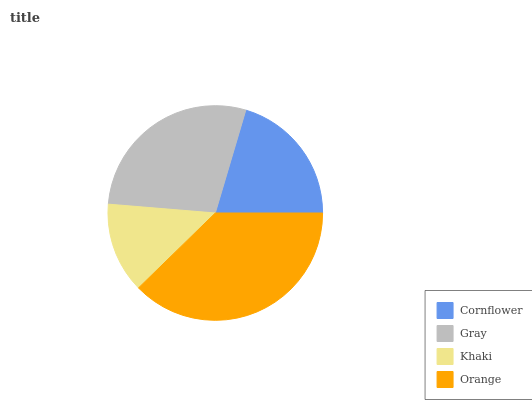Is Khaki the minimum?
Answer yes or no. Yes. Is Orange the maximum?
Answer yes or no. Yes. Is Gray the minimum?
Answer yes or no. No. Is Gray the maximum?
Answer yes or no. No. Is Gray greater than Cornflower?
Answer yes or no. Yes. Is Cornflower less than Gray?
Answer yes or no. Yes. Is Cornflower greater than Gray?
Answer yes or no. No. Is Gray less than Cornflower?
Answer yes or no. No. Is Gray the high median?
Answer yes or no. Yes. Is Cornflower the low median?
Answer yes or no. Yes. Is Cornflower the high median?
Answer yes or no. No. Is Orange the low median?
Answer yes or no. No. 